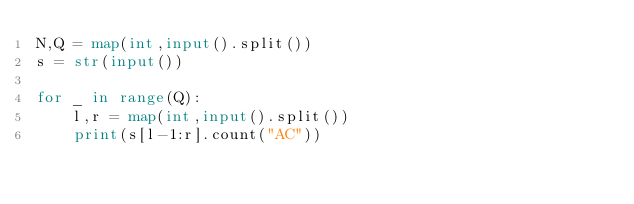Convert code to text. <code><loc_0><loc_0><loc_500><loc_500><_Python_>N,Q = map(int,input().split())
s = str(input())

for _ in range(Q):
    l,r = map(int,input().split())
    print(s[l-1:r].count("AC"))</code> 